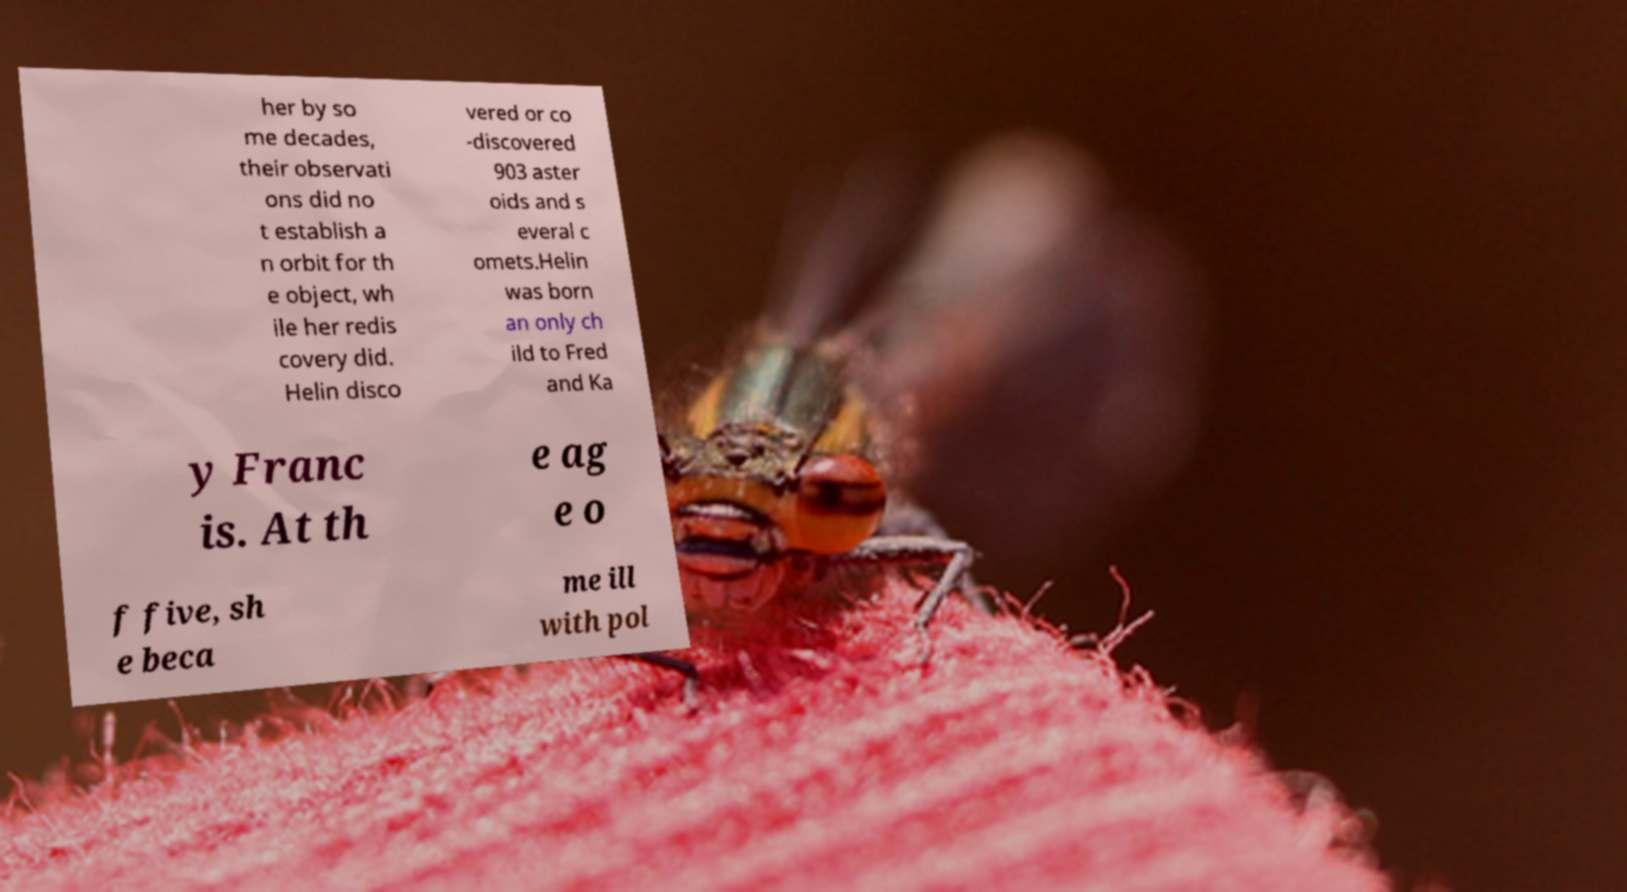For documentation purposes, I need the text within this image transcribed. Could you provide that? her by so me decades, their observati ons did no t establish a n orbit for th e object, wh ile her redis covery did. Helin disco vered or co -discovered 903 aster oids and s everal c omets.Helin was born an only ch ild to Fred and Ka y Franc is. At th e ag e o f five, sh e beca me ill with pol 